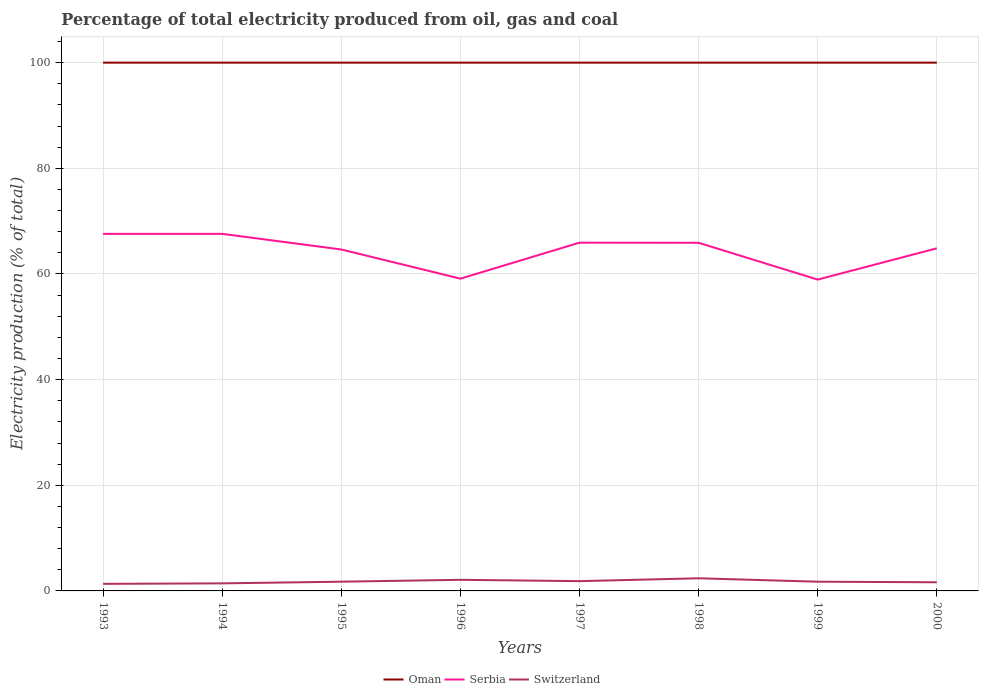How many different coloured lines are there?
Ensure brevity in your answer.  3. Does the line corresponding to Switzerland intersect with the line corresponding to Oman?
Provide a succinct answer. No. Across all years, what is the maximum electricity production in in Switzerland?
Ensure brevity in your answer.  1.34. What is the total electricity production in in Switzerland in the graph?
Ensure brevity in your answer.  -0.29. What is the difference between the highest and the second highest electricity production in in Serbia?
Ensure brevity in your answer.  8.66. What is the difference between the highest and the lowest electricity production in in Oman?
Provide a succinct answer. 0. How many lines are there?
Offer a terse response. 3. What is the difference between two consecutive major ticks on the Y-axis?
Provide a short and direct response. 20. Are the values on the major ticks of Y-axis written in scientific E-notation?
Offer a very short reply. No. Does the graph contain grids?
Keep it short and to the point. Yes. How many legend labels are there?
Provide a short and direct response. 3. How are the legend labels stacked?
Provide a succinct answer. Horizontal. What is the title of the graph?
Your answer should be very brief. Percentage of total electricity produced from oil, gas and coal. Does "South Sudan" appear as one of the legend labels in the graph?
Provide a succinct answer. No. What is the label or title of the Y-axis?
Ensure brevity in your answer.  Electricity production (% of total). What is the Electricity production (% of total) in Oman in 1993?
Your answer should be very brief. 100. What is the Electricity production (% of total) in Serbia in 1993?
Ensure brevity in your answer.  67.59. What is the Electricity production (% of total) in Switzerland in 1993?
Provide a short and direct response. 1.34. What is the Electricity production (% of total) of Serbia in 1994?
Provide a short and direct response. 67.59. What is the Electricity production (% of total) of Switzerland in 1994?
Your response must be concise. 1.43. What is the Electricity production (% of total) of Oman in 1995?
Your response must be concise. 100. What is the Electricity production (% of total) of Serbia in 1995?
Make the answer very short. 64.63. What is the Electricity production (% of total) of Switzerland in 1995?
Offer a terse response. 1.75. What is the Electricity production (% of total) in Serbia in 1996?
Offer a very short reply. 59.11. What is the Electricity production (% of total) of Switzerland in 1996?
Your answer should be very brief. 2.1. What is the Electricity production (% of total) in Oman in 1997?
Your answer should be compact. 100. What is the Electricity production (% of total) of Serbia in 1997?
Your answer should be compact. 65.92. What is the Electricity production (% of total) of Switzerland in 1997?
Provide a succinct answer. 1.85. What is the Electricity production (% of total) in Oman in 1998?
Ensure brevity in your answer.  100. What is the Electricity production (% of total) in Serbia in 1998?
Ensure brevity in your answer.  65.9. What is the Electricity production (% of total) in Switzerland in 1998?
Your answer should be very brief. 2.39. What is the Electricity production (% of total) of Oman in 1999?
Your response must be concise. 100. What is the Electricity production (% of total) in Serbia in 1999?
Your answer should be very brief. 58.93. What is the Electricity production (% of total) of Switzerland in 1999?
Your answer should be very brief. 1.74. What is the Electricity production (% of total) of Serbia in 2000?
Provide a short and direct response. 64.85. What is the Electricity production (% of total) of Switzerland in 2000?
Offer a terse response. 1.64. Across all years, what is the maximum Electricity production (% of total) of Oman?
Make the answer very short. 100. Across all years, what is the maximum Electricity production (% of total) in Serbia?
Offer a terse response. 67.59. Across all years, what is the maximum Electricity production (% of total) in Switzerland?
Your answer should be compact. 2.39. Across all years, what is the minimum Electricity production (% of total) in Oman?
Ensure brevity in your answer.  100. Across all years, what is the minimum Electricity production (% of total) of Serbia?
Offer a terse response. 58.93. Across all years, what is the minimum Electricity production (% of total) of Switzerland?
Offer a terse response. 1.34. What is the total Electricity production (% of total) in Oman in the graph?
Provide a short and direct response. 800. What is the total Electricity production (% of total) in Serbia in the graph?
Keep it short and to the point. 514.53. What is the total Electricity production (% of total) in Switzerland in the graph?
Make the answer very short. 14.25. What is the difference between the Electricity production (% of total) in Oman in 1993 and that in 1994?
Provide a short and direct response. 0. What is the difference between the Electricity production (% of total) of Serbia in 1993 and that in 1994?
Make the answer very short. 0. What is the difference between the Electricity production (% of total) in Switzerland in 1993 and that in 1994?
Make the answer very short. -0.09. What is the difference between the Electricity production (% of total) in Serbia in 1993 and that in 1995?
Ensure brevity in your answer.  2.96. What is the difference between the Electricity production (% of total) in Switzerland in 1993 and that in 1995?
Your answer should be very brief. -0.41. What is the difference between the Electricity production (% of total) of Oman in 1993 and that in 1996?
Your response must be concise. 0. What is the difference between the Electricity production (% of total) in Serbia in 1993 and that in 1996?
Offer a very short reply. 8.48. What is the difference between the Electricity production (% of total) of Switzerland in 1993 and that in 1996?
Make the answer very short. -0.76. What is the difference between the Electricity production (% of total) of Serbia in 1993 and that in 1997?
Your answer should be compact. 1.67. What is the difference between the Electricity production (% of total) in Switzerland in 1993 and that in 1997?
Your response must be concise. -0.51. What is the difference between the Electricity production (% of total) in Serbia in 1993 and that in 1998?
Ensure brevity in your answer.  1.69. What is the difference between the Electricity production (% of total) in Switzerland in 1993 and that in 1998?
Give a very brief answer. -1.05. What is the difference between the Electricity production (% of total) in Oman in 1993 and that in 1999?
Give a very brief answer. 0. What is the difference between the Electricity production (% of total) of Serbia in 1993 and that in 1999?
Your answer should be compact. 8.66. What is the difference between the Electricity production (% of total) of Switzerland in 1993 and that in 1999?
Give a very brief answer. -0.41. What is the difference between the Electricity production (% of total) of Oman in 1993 and that in 2000?
Make the answer very short. 0. What is the difference between the Electricity production (% of total) in Serbia in 1993 and that in 2000?
Offer a very short reply. 2.74. What is the difference between the Electricity production (% of total) in Switzerland in 1993 and that in 2000?
Offer a very short reply. -0.3. What is the difference between the Electricity production (% of total) in Serbia in 1994 and that in 1995?
Offer a very short reply. 2.96. What is the difference between the Electricity production (% of total) in Switzerland in 1994 and that in 1995?
Give a very brief answer. -0.32. What is the difference between the Electricity production (% of total) of Serbia in 1994 and that in 1996?
Offer a very short reply. 8.48. What is the difference between the Electricity production (% of total) of Switzerland in 1994 and that in 1996?
Make the answer very short. -0.67. What is the difference between the Electricity production (% of total) in Serbia in 1994 and that in 1997?
Offer a terse response. 1.67. What is the difference between the Electricity production (% of total) in Switzerland in 1994 and that in 1997?
Provide a short and direct response. -0.42. What is the difference between the Electricity production (% of total) of Oman in 1994 and that in 1998?
Keep it short and to the point. 0. What is the difference between the Electricity production (% of total) of Serbia in 1994 and that in 1998?
Keep it short and to the point. 1.69. What is the difference between the Electricity production (% of total) in Switzerland in 1994 and that in 1998?
Ensure brevity in your answer.  -0.96. What is the difference between the Electricity production (% of total) in Serbia in 1994 and that in 1999?
Provide a succinct answer. 8.66. What is the difference between the Electricity production (% of total) of Switzerland in 1994 and that in 1999?
Make the answer very short. -0.31. What is the difference between the Electricity production (% of total) of Serbia in 1994 and that in 2000?
Make the answer very short. 2.74. What is the difference between the Electricity production (% of total) in Switzerland in 1994 and that in 2000?
Make the answer very short. -0.21. What is the difference between the Electricity production (% of total) of Serbia in 1995 and that in 1996?
Offer a terse response. 5.53. What is the difference between the Electricity production (% of total) of Switzerland in 1995 and that in 1996?
Keep it short and to the point. -0.35. What is the difference between the Electricity production (% of total) of Oman in 1995 and that in 1997?
Your response must be concise. 0. What is the difference between the Electricity production (% of total) of Serbia in 1995 and that in 1997?
Your answer should be compact. -1.29. What is the difference between the Electricity production (% of total) in Switzerland in 1995 and that in 1997?
Your answer should be very brief. -0.1. What is the difference between the Electricity production (% of total) in Oman in 1995 and that in 1998?
Your answer should be very brief. 0. What is the difference between the Electricity production (% of total) of Serbia in 1995 and that in 1998?
Your answer should be compact. -1.27. What is the difference between the Electricity production (% of total) in Switzerland in 1995 and that in 1998?
Make the answer very short. -0.65. What is the difference between the Electricity production (% of total) in Serbia in 1995 and that in 1999?
Provide a succinct answer. 5.7. What is the difference between the Electricity production (% of total) of Switzerland in 1995 and that in 1999?
Offer a very short reply. 0. What is the difference between the Electricity production (% of total) in Oman in 1995 and that in 2000?
Keep it short and to the point. 0. What is the difference between the Electricity production (% of total) of Serbia in 1995 and that in 2000?
Ensure brevity in your answer.  -0.22. What is the difference between the Electricity production (% of total) in Switzerland in 1995 and that in 2000?
Your answer should be very brief. 0.11. What is the difference between the Electricity production (% of total) in Oman in 1996 and that in 1997?
Provide a short and direct response. 0. What is the difference between the Electricity production (% of total) in Serbia in 1996 and that in 1997?
Provide a succinct answer. -6.81. What is the difference between the Electricity production (% of total) of Switzerland in 1996 and that in 1997?
Keep it short and to the point. 0.25. What is the difference between the Electricity production (% of total) in Oman in 1996 and that in 1998?
Keep it short and to the point. 0. What is the difference between the Electricity production (% of total) of Serbia in 1996 and that in 1998?
Ensure brevity in your answer.  -6.79. What is the difference between the Electricity production (% of total) of Switzerland in 1996 and that in 1998?
Offer a terse response. -0.29. What is the difference between the Electricity production (% of total) of Serbia in 1996 and that in 1999?
Offer a terse response. 0.17. What is the difference between the Electricity production (% of total) in Switzerland in 1996 and that in 1999?
Your answer should be very brief. 0.36. What is the difference between the Electricity production (% of total) in Oman in 1996 and that in 2000?
Your answer should be compact. 0. What is the difference between the Electricity production (% of total) in Serbia in 1996 and that in 2000?
Your answer should be compact. -5.74. What is the difference between the Electricity production (% of total) of Switzerland in 1996 and that in 2000?
Offer a terse response. 0.46. What is the difference between the Electricity production (% of total) of Oman in 1997 and that in 1998?
Give a very brief answer. 0. What is the difference between the Electricity production (% of total) in Serbia in 1997 and that in 1998?
Offer a terse response. 0.02. What is the difference between the Electricity production (% of total) in Switzerland in 1997 and that in 1998?
Your answer should be compact. -0.54. What is the difference between the Electricity production (% of total) in Serbia in 1997 and that in 1999?
Provide a short and direct response. 6.99. What is the difference between the Electricity production (% of total) of Switzerland in 1997 and that in 1999?
Offer a terse response. 0.11. What is the difference between the Electricity production (% of total) in Serbia in 1997 and that in 2000?
Ensure brevity in your answer.  1.07. What is the difference between the Electricity production (% of total) in Switzerland in 1997 and that in 2000?
Make the answer very short. 0.21. What is the difference between the Electricity production (% of total) of Oman in 1998 and that in 1999?
Your answer should be very brief. 0. What is the difference between the Electricity production (% of total) of Serbia in 1998 and that in 1999?
Your answer should be compact. 6.97. What is the difference between the Electricity production (% of total) of Switzerland in 1998 and that in 1999?
Keep it short and to the point. 0.65. What is the difference between the Electricity production (% of total) of Oman in 1998 and that in 2000?
Your response must be concise. 0. What is the difference between the Electricity production (% of total) of Serbia in 1998 and that in 2000?
Keep it short and to the point. 1.05. What is the difference between the Electricity production (% of total) in Switzerland in 1998 and that in 2000?
Ensure brevity in your answer.  0.75. What is the difference between the Electricity production (% of total) in Oman in 1999 and that in 2000?
Provide a short and direct response. 0. What is the difference between the Electricity production (% of total) of Serbia in 1999 and that in 2000?
Ensure brevity in your answer.  -5.92. What is the difference between the Electricity production (% of total) in Switzerland in 1999 and that in 2000?
Provide a short and direct response. 0.11. What is the difference between the Electricity production (% of total) of Oman in 1993 and the Electricity production (% of total) of Serbia in 1994?
Make the answer very short. 32.41. What is the difference between the Electricity production (% of total) of Oman in 1993 and the Electricity production (% of total) of Switzerland in 1994?
Your answer should be compact. 98.57. What is the difference between the Electricity production (% of total) of Serbia in 1993 and the Electricity production (% of total) of Switzerland in 1994?
Provide a short and direct response. 66.16. What is the difference between the Electricity production (% of total) of Oman in 1993 and the Electricity production (% of total) of Serbia in 1995?
Offer a terse response. 35.37. What is the difference between the Electricity production (% of total) of Oman in 1993 and the Electricity production (% of total) of Switzerland in 1995?
Your answer should be very brief. 98.25. What is the difference between the Electricity production (% of total) of Serbia in 1993 and the Electricity production (% of total) of Switzerland in 1995?
Offer a terse response. 65.84. What is the difference between the Electricity production (% of total) of Oman in 1993 and the Electricity production (% of total) of Serbia in 1996?
Keep it short and to the point. 40.89. What is the difference between the Electricity production (% of total) of Oman in 1993 and the Electricity production (% of total) of Switzerland in 1996?
Provide a succinct answer. 97.9. What is the difference between the Electricity production (% of total) in Serbia in 1993 and the Electricity production (% of total) in Switzerland in 1996?
Your answer should be very brief. 65.49. What is the difference between the Electricity production (% of total) of Oman in 1993 and the Electricity production (% of total) of Serbia in 1997?
Offer a very short reply. 34.08. What is the difference between the Electricity production (% of total) of Oman in 1993 and the Electricity production (% of total) of Switzerland in 1997?
Give a very brief answer. 98.15. What is the difference between the Electricity production (% of total) of Serbia in 1993 and the Electricity production (% of total) of Switzerland in 1997?
Offer a very short reply. 65.74. What is the difference between the Electricity production (% of total) of Oman in 1993 and the Electricity production (% of total) of Serbia in 1998?
Your answer should be compact. 34.1. What is the difference between the Electricity production (% of total) in Oman in 1993 and the Electricity production (% of total) in Switzerland in 1998?
Your answer should be compact. 97.61. What is the difference between the Electricity production (% of total) of Serbia in 1993 and the Electricity production (% of total) of Switzerland in 1998?
Ensure brevity in your answer.  65.2. What is the difference between the Electricity production (% of total) of Oman in 1993 and the Electricity production (% of total) of Serbia in 1999?
Your answer should be compact. 41.07. What is the difference between the Electricity production (% of total) of Oman in 1993 and the Electricity production (% of total) of Switzerland in 1999?
Provide a succinct answer. 98.26. What is the difference between the Electricity production (% of total) in Serbia in 1993 and the Electricity production (% of total) in Switzerland in 1999?
Provide a succinct answer. 65.85. What is the difference between the Electricity production (% of total) in Oman in 1993 and the Electricity production (% of total) in Serbia in 2000?
Your response must be concise. 35.15. What is the difference between the Electricity production (% of total) in Oman in 1993 and the Electricity production (% of total) in Switzerland in 2000?
Offer a terse response. 98.36. What is the difference between the Electricity production (% of total) in Serbia in 1993 and the Electricity production (% of total) in Switzerland in 2000?
Ensure brevity in your answer.  65.95. What is the difference between the Electricity production (% of total) in Oman in 1994 and the Electricity production (% of total) in Serbia in 1995?
Offer a very short reply. 35.37. What is the difference between the Electricity production (% of total) in Oman in 1994 and the Electricity production (% of total) in Switzerland in 1995?
Your answer should be very brief. 98.25. What is the difference between the Electricity production (% of total) of Serbia in 1994 and the Electricity production (% of total) of Switzerland in 1995?
Your response must be concise. 65.84. What is the difference between the Electricity production (% of total) of Oman in 1994 and the Electricity production (% of total) of Serbia in 1996?
Offer a terse response. 40.89. What is the difference between the Electricity production (% of total) in Oman in 1994 and the Electricity production (% of total) in Switzerland in 1996?
Provide a short and direct response. 97.9. What is the difference between the Electricity production (% of total) in Serbia in 1994 and the Electricity production (% of total) in Switzerland in 1996?
Give a very brief answer. 65.49. What is the difference between the Electricity production (% of total) of Oman in 1994 and the Electricity production (% of total) of Serbia in 1997?
Offer a very short reply. 34.08. What is the difference between the Electricity production (% of total) of Oman in 1994 and the Electricity production (% of total) of Switzerland in 1997?
Provide a succinct answer. 98.15. What is the difference between the Electricity production (% of total) of Serbia in 1994 and the Electricity production (% of total) of Switzerland in 1997?
Give a very brief answer. 65.74. What is the difference between the Electricity production (% of total) of Oman in 1994 and the Electricity production (% of total) of Serbia in 1998?
Your answer should be compact. 34.1. What is the difference between the Electricity production (% of total) of Oman in 1994 and the Electricity production (% of total) of Switzerland in 1998?
Provide a short and direct response. 97.61. What is the difference between the Electricity production (% of total) of Serbia in 1994 and the Electricity production (% of total) of Switzerland in 1998?
Keep it short and to the point. 65.2. What is the difference between the Electricity production (% of total) in Oman in 1994 and the Electricity production (% of total) in Serbia in 1999?
Make the answer very short. 41.07. What is the difference between the Electricity production (% of total) of Oman in 1994 and the Electricity production (% of total) of Switzerland in 1999?
Your answer should be compact. 98.26. What is the difference between the Electricity production (% of total) of Serbia in 1994 and the Electricity production (% of total) of Switzerland in 1999?
Your answer should be compact. 65.85. What is the difference between the Electricity production (% of total) of Oman in 1994 and the Electricity production (% of total) of Serbia in 2000?
Make the answer very short. 35.15. What is the difference between the Electricity production (% of total) of Oman in 1994 and the Electricity production (% of total) of Switzerland in 2000?
Give a very brief answer. 98.36. What is the difference between the Electricity production (% of total) of Serbia in 1994 and the Electricity production (% of total) of Switzerland in 2000?
Ensure brevity in your answer.  65.95. What is the difference between the Electricity production (% of total) of Oman in 1995 and the Electricity production (% of total) of Serbia in 1996?
Your answer should be very brief. 40.89. What is the difference between the Electricity production (% of total) in Oman in 1995 and the Electricity production (% of total) in Switzerland in 1996?
Your answer should be very brief. 97.9. What is the difference between the Electricity production (% of total) of Serbia in 1995 and the Electricity production (% of total) of Switzerland in 1996?
Make the answer very short. 62.53. What is the difference between the Electricity production (% of total) of Oman in 1995 and the Electricity production (% of total) of Serbia in 1997?
Offer a very short reply. 34.08. What is the difference between the Electricity production (% of total) in Oman in 1995 and the Electricity production (% of total) in Switzerland in 1997?
Make the answer very short. 98.15. What is the difference between the Electricity production (% of total) of Serbia in 1995 and the Electricity production (% of total) of Switzerland in 1997?
Keep it short and to the point. 62.78. What is the difference between the Electricity production (% of total) in Oman in 1995 and the Electricity production (% of total) in Serbia in 1998?
Your answer should be very brief. 34.1. What is the difference between the Electricity production (% of total) of Oman in 1995 and the Electricity production (% of total) of Switzerland in 1998?
Provide a succinct answer. 97.61. What is the difference between the Electricity production (% of total) of Serbia in 1995 and the Electricity production (% of total) of Switzerland in 1998?
Your answer should be very brief. 62.24. What is the difference between the Electricity production (% of total) in Oman in 1995 and the Electricity production (% of total) in Serbia in 1999?
Your response must be concise. 41.07. What is the difference between the Electricity production (% of total) in Oman in 1995 and the Electricity production (% of total) in Switzerland in 1999?
Provide a succinct answer. 98.26. What is the difference between the Electricity production (% of total) of Serbia in 1995 and the Electricity production (% of total) of Switzerland in 1999?
Ensure brevity in your answer.  62.89. What is the difference between the Electricity production (% of total) of Oman in 1995 and the Electricity production (% of total) of Serbia in 2000?
Offer a terse response. 35.15. What is the difference between the Electricity production (% of total) of Oman in 1995 and the Electricity production (% of total) of Switzerland in 2000?
Make the answer very short. 98.36. What is the difference between the Electricity production (% of total) in Serbia in 1995 and the Electricity production (% of total) in Switzerland in 2000?
Provide a short and direct response. 62.99. What is the difference between the Electricity production (% of total) of Oman in 1996 and the Electricity production (% of total) of Serbia in 1997?
Provide a succinct answer. 34.08. What is the difference between the Electricity production (% of total) of Oman in 1996 and the Electricity production (% of total) of Switzerland in 1997?
Provide a succinct answer. 98.15. What is the difference between the Electricity production (% of total) of Serbia in 1996 and the Electricity production (% of total) of Switzerland in 1997?
Give a very brief answer. 57.26. What is the difference between the Electricity production (% of total) in Oman in 1996 and the Electricity production (% of total) in Serbia in 1998?
Keep it short and to the point. 34.1. What is the difference between the Electricity production (% of total) in Oman in 1996 and the Electricity production (% of total) in Switzerland in 1998?
Your answer should be compact. 97.61. What is the difference between the Electricity production (% of total) in Serbia in 1996 and the Electricity production (% of total) in Switzerland in 1998?
Your answer should be compact. 56.71. What is the difference between the Electricity production (% of total) in Oman in 1996 and the Electricity production (% of total) in Serbia in 1999?
Make the answer very short. 41.07. What is the difference between the Electricity production (% of total) of Oman in 1996 and the Electricity production (% of total) of Switzerland in 1999?
Offer a very short reply. 98.26. What is the difference between the Electricity production (% of total) in Serbia in 1996 and the Electricity production (% of total) in Switzerland in 1999?
Ensure brevity in your answer.  57.36. What is the difference between the Electricity production (% of total) of Oman in 1996 and the Electricity production (% of total) of Serbia in 2000?
Make the answer very short. 35.15. What is the difference between the Electricity production (% of total) in Oman in 1996 and the Electricity production (% of total) in Switzerland in 2000?
Give a very brief answer. 98.36. What is the difference between the Electricity production (% of total) in Serbia in 1996 and the Electricity production (% of total) in Switzerland in 2000?
Your answer should be very brief. 57.47. What is the difference between the Electricity production (% of total) in Oman in 1997 and the Electricity production (% of total) in Serbia in 1998?
Your answer should be compact. 34.1. What is the difference between the Electricity production (% of total) of Oman in 1997 and the Electricity production (% of total) of Switzerland in 1998?
Keep it short and to the point. 97.61. What is the difference between the Electricity production (% of total) in Serbia in 1997 and the Electricity production (% of total) in Switzerland in 1998?
Ensure brevity in your answer.  63.53. What is the difference between the Electricity production (% of total) of Oman in 1997 and the Electricity production (% of total) of Serbia in 1999?
Your answer should be very brief. 41.07. What is the difference between the Electricity production (% of total) of Oman in 1997 and the Electricity production (% of total) of Switzerland in 1999?
Ensure brevity in your answer.  98.26. What is the difference between the Electricity production (% of total) of Serbia in 1997 and the Electricity production (% of total) of Switzerland in 1999?
Provide a short and direct response. 64.18. What is the difference between the Electricity production (% of total) of Oman in 1997 and the Electricity production (% of total) of Serbia in 2000?
Provide a succinct answer. 35.15. What is the difference between the Electricity production (% of total) in Oman in 1997 and the Electricity production (% of total) in Switzerland in 2000?
Your answer should be very brief. 98.36. What is the difference between the Electricity production (% of total) in Serbia in 1997 and the Electricity production (% of total) in Switzerland in 2000?
Provide a succinct answer. 64.28. What is the difference between the Electricity production (% of total) in Oman in 1998 and the Electricity production (% of total) in Serbia in 1999?
Your response must be concise. 41.07. What is the difference between the Electricity production (% of total) of Oman in 1998 and the Electricity production (% of total) of Switzerland in 1999?
Ensure brevity in your answer.  98.26. What is the difference between the Electricity production (% of total) of Serbia in 1998 and the Electricity production (% of total) of Switzerland in 1999?
Your answer should be very brief. 64.16. What is the difference between the Electricity production (% of total) in Oman in 1998 and the Electricity production (% of total) in Serbia in 2000?
Make the answer very short. 35.15. What is the difference between the Electricity production (% of total) of Oman in 1998 and the Electricity production (% of total) of Switzerland in 2000?
Offer a terse response. 98.36. What is the difference between the Electricity production (% of total) in Serbia in 1998 and the Electricity production (% of total) in Switzerland in 2000?
Provide a short and direct response. 64.26. What is the difference between the Electricity production (% of total) in Oman in 1999 and the Electricity production (% of total) in Serbia in 2000?
Keep it short and to the point. 35.15. What is the difference between the Electricity production (% of total) of Oman in 1999 and the Electricity production (% of total) of Switzerland in 2000?
Your response must be concise. 98.36. What is the difference between the Electricity production (% of total) of Serbia in 1999 and the Electricity production (% of total) of Switzerland in 2000?
Your answer should be compact. 57.3. What is the average Electricity production (% of total) in Oman per year?
Ensure brevity in your answer.  100. What is the average Electricity production (% of total) in Serbia per year?
Your answer should be compact. 64.32. What is the average Electricity production (% of total) of Switzerland per year?
Give a very brief answer. 1.78. In the year 1993, what is the difference between the Electricity production (% of total) in Oman and Electricity production (% of total) in Serbia?
Keep it short and to the point. 32.41. In the year 1993, what is the difference between the Electricity production (% of total) of Oman and Electricity production (% of total) of Switzerland?
Provide a short and direct response. 98.66. In the year 1993, what is the difference between the Electricity production (% of total) in Serbia and Electricity production (% of total) in Switzerland?
Your response must be concise. 66.25. In the year 1994, what is the difference between the Electricity production (% of total) of Oman and Electricity production (% of total) of Serbia?
Provide a short and direct response. 32.41. In the year 1994, what is the difference between the Electricity production (% of total) of Oman and Electricity production (% of total) of Switzerland?
Offer a very short reply. 98.57. In the year 1994, what is the difference between the Electricity production (% of total) in Serbia and Electricity production (% of total) in Switzerland?
Keep it short and to the point. 66.16. In the year 1995, what is the difference between the Electricity production (% of total) of Oman and Electricity production (% of total) of Serbia?
Provide a succinct answer. 35.37. In the year 1995, what is the difference between the Electricity production (% of total) of Oman and Electricity production (% of total) of Switzerland?
Provide a short and direct response. 98.25. In the year 1995, what is the difference between the Electricity production (% of total) in Serbia and Electricity production (% of total) in Switzerland?
Ensure brevity in your answer.  62.89. In the year 1996, what is the difference between the Electricity production (% of total) of Oman and Electricity production (% of total) of Serbia?
Your response must be concise. 40.89. In the year 1996, what is the difference between the Electricity production (% of total) in Oman and Electricity production (% of total) in Switzerland?
Your answer should be very brief. 97.9. In the year 1996, what is the difference between the Electricity production (% of total) of Serbia and Electricity production (% of total) of Switzerland?
Provide a short and direct response. 57.01. In the year 1997, what is the difference between the Electricity production (% of total) of Oman and Electricity production (% of total) of Serbia?
Your response must be concise. 34.08. In the year 1997, what is the difference between the Electricity production (% of total) of Oman and Electricity production (% of total) of Switzerland?
Your answer should be very brief. 98.15. In the year 1997, what is the difference between the Electricity production (% of total) in Serbia and Electricity production (% of total) in Switzerland?
Keep it short and to the point. 64.07. In the year 1998, what is the difference between the Electricity production (% of total) in Oman and Electricity production (% of total) in Serbia?
Offer a very short reply. 34.1. In the year 1998, what is the difference between the Electricity production (% of total) in Oman and Electricity production (% of total) in Switzerland?
Ensure brevity in your answer.  97.61. In the year 1998, what is the difference between the Electricity production (% of total) in Serbia and Electricity production (% of total) in Switzerland?
Ensure brevity in your answer.  63.51. In the year 1999, what is the difference between the Electricity production (% of total) of Oman and Electricity production (% of total) of Serbia?
Your response must be concise. 41.07. In the year 1999, what is the difference between the Electricity production (% of total) in Oman and Electricity production (% of total) in Switzerland?
Your response must be concise. 98.26. In the year 1999, what is the difference between the Electricity production (% of total) in Serbia and Electricity production (% of total) in Switzerland?
Give a very brief answer. 57.19. In the year 2000, what is the difference between the Electricity production (% of total) in Oman and Electricity production (% of total) in Serbia?
Give a very brief answer. 35.15. In the year 2000, what is the difference between the Electricity production (% of total) in Oman and Electricity production (% of total) in Switzerland?
Give a very brief answer. 98.36. In the year 2000, what is the difference between the Electricity production (% of total) of Serbia and Electricity production (% of total) of Switzerland?
Ensure brevity in your answer.  63.21. What is the ratio of the Electricity production (% of total) in Oman in 1993 to that in 1994?
Keep it short and to the point. 1. What is the ratio of the Electricity production (% of total) of Switzerland in 1993 to that in 1994?
Provide a succinct answer. 0.94. What is the ratio of the Electricity production (% of total) of Serbia in 1993 to that in 1995?
Offer a terse response. 1.05. What is the ratio of the Electricity production (% of total) of Switzerland in 1993 to that in 1995?
Give a very brief answer. 0.77. What is the ratio of the Electricity production (% of total) in Oman in 1993 to that in 1996?
Offer a very short reply. 1. What is the ratio of the Electricity production (% of total) of Serbia in 1993 to that in 1996?
Keep it short and to the point. 1.14. What is the ratio of the Electricity production (% of total) in Switzerland in 1993 to that in 1996?
Provide a short and direct response. 0.64. What is the ratio of the Electricity production (% of total) in Serbia in 1993 to that in 1997?
Your answer should be very brief. 1.03. What is the ratio of the Electricity production (% of total) in Switzerland in 1993 to that in 1997?
Offer a very short reply. 0.72. What is the ratio of the Electricity production (% of total) in Oman in 1993 to that in 1998?
Your answer should be very brief. 1. What is the ratio of the Electricity production (% of total) of Serbia in 1993 to that in 1998?
Provide a succinct answer. 1.03. What is the ratio of the Electricity production (% of total) in Switzerland in 1993 to that in 1998?
Keep it short and to the point. 0.56. What is the ratio of the Electricity production (% of total) in Oman in 1993 to that in 1999?
Your response must be concise. 1. What is the ratio of the Electricity production (% of total) of Serbia in 1993 to that in 1999?
Your answer should be very brief. 1.15. What is the ratio of the Electricity production (% of total) of Switzerland in 1993 to that in 1999?
Make the answer very short. 0.77. What is the ratio of the Electricity production (% of total) in Serbia in 1993 to that in 2000?
Make the answer very short. 1.04. What is the ratio of the Electricity production (% of total) in Switzerland in 1993 to that in 2000?
Provide a short and direct response. 0.82. What is the ratio of the Electricity production (% of total) of Serbia in 1994 to that in 1995?
Provide a succinct answer. 1.05. What is the ratio of the Electricity production (% of total) of Switzerland in 1994 to that in 1995?
Your answer should be very brief. 0.82. What is the ratio of the Electricity production (% of total) of Oman in 1994 to that in 1996?
Your answer should be very brief. 1. What is the ratio of the Electricity production (% of total) in Serbia in 1994 to that in 1996?
Make the answer very short. 1.14. What is the ratio of the Electricity production (% of total) of Switzerland in 1994 to that in 1996?
Provide a succinct answer. 0.68. What is the ratio of the Electricity production (% of total) in Serbia in 1994 to that in 1997?
Ensure brevity in your answer.  1.03. What is the ratio of the Electricity production (% of total) in Switzerland in 1994 to that in 1997?
Your response must be concise. 0.77. What is the ratio of the Electricity production (% of total) of Serbia in 1994 to that in 1998?
Provide a short and direct response. 1.03. What is the ratio of the Electricity production (% of total) of Switzerland in 1994 to that in 1998?
Give a very brief answer. 0.6. What is the ratio of the Electricity production (% of total) of Serbia in 1994 to that in 1999?
Give a very brief answer. 1.15. What is the ratio of the Electricity production (% of total) in Switzerland in 1994 to that in 1999?
Your answer should be very brief. 0.82. What is the ratio of the Electricity production (% of total) in Oman in 1994 to that in 2000?
Keep it short and to the point. 1. What is the ratio of the Electricity production (% of total) of Serbia in 1994 to that in 2000?
Keep it short and to the point. 1.04. What is the ratio of the Electricity production (% of total) in Switzerland in 1994 to that in 2000?
Your answer should be very brief. 0.87. What is the ratio of the Electricity production (% of total) of Serbia in 1995 to that in 1996?
Give a very brief answer. 1.09. What is the ratio of the Electricity production (% of total) of Switzerland in 1995 to that in 1996?
Ensure brevity in your answer.  0.83. What is the ratio of the Electricity production (% of total) in Oman in 1995 to that in 1997?
Offer a very short reply. 1. What is the ratio of the Electricity production (% of total) of Serbia in 1995 to that in 1997?
Ensure brevity in your answer.  0.98. What is the ratio of the Electricity production (% of total) of Switzerland in 1995 to that in 1997?
Your response must be concise. 0.94. What is the ratio of the Electricity production (% of total) in Serbia in 1995 to that in 1998?
Provide a succinct answer. 0.98. What is the ratio of the Electricity production (% of total) of Switzerland in 1995 to that in 1998?
Provide a succinct answer. 0.73. What is the ratio of the Electricity production (% of total) of Oman in 1995 to that in 1999?
Make the answer very short. 1. What is the ratio of the Electricity production (% of total) of Serbia in 1995 to that in 1999?
Keep it short and to the point. 1.1. What is the ratio of the Electricity production (% of total) in Switzerland in 1995 to that in 1999?
Provide a short and direct response. 1. What is the ratio of the Electricity production (% of total) of Oman in 1995 to that in 2000?
Offer a terse response. 1. What is the ratio of the Electricity production (% of total) of Serbia in 1995 to that in 2000?
Your answer should be very brief. 1. What is the ratio of the Electricity production (% of total) in Switzerland in 1995 to that in 2000?
Provide a succinct answer. 1.07. What is the ratio of the Electricity production (% of total) in Oman in 1996 to that in 1997?
Your answer should be very brief. 1. What is the ratio of the Electricity production (% of total) of Serbia in 1996 to that in 1997?
Give a very brief answer. 0.9. What is the ratio of the Electricity production (% of total) of Switzerland in 1996 to that in 1997?
Provide a short and direct response. 1.13. What is the ratio of the Electricity production (% of total) in Serbia in 1996 to that in 1998?
Provide a short and direct response. 0.9. What is the ratio of the Electricity production (% of total) of Switzerland in 1996 to that in 1998?
Give a very brief answer. 0.88. What is the ratio of the Electricity production (% of total) of Serbia in 1996 to that in 1999?
Provide a short and direct response. 1. What is the ratio of the Electricity production (% of total) of Switzerland in 1996 to that in 1999?
Ensure brevity in your answer.  1.2. What is the ratio of the Electricity production (% of total) of Oman in 1996 to that in 2000?
Ensure brevity in your answer.  1. What is the ratio of the Electricity production (% of total) of Serbia in 1996 to that in 2000?
Your answer should be very brief. 0.91. What is the ratio of the Electricity production (% of total) of Switzerland in 1996 to that in 2000?
Give a very brief answer. 1.28. What is the ratio of the Electricity production (% of total) of Switzerland in 1997 to that in 1998?
Your response must be concise. 0.77. What is the ratio of the Electricity production (% of total) of Oman in 1997 to that in 1999?
Your answer should be compact. 1. What is the ratio of the Electricity production (% of total) of Serbia in 1997 to that in 1999?
Keep it short and to the point. 1.12. What is the ratio of the Electricity production (% of total) of Switzerland in 1997 to that in 1999?
Provide a short and direct response. 1.06. What is the ratio of the Electricity production (% of total) in Serbia in 1997 to that in 2000?
Your answer should be compact. 1.02. What is the ratio of the Electricity production (% of total) in Switzerland in 1997 to that in 2000?
Ensure brevity in your answer.  1.13. What is the ratio of the Electricity production (% of total) of Serbia in 1998 to that in 1999?
Your response must be concise. 1.12. What is the ratio of the Electricity production (% of total) in Switzerland in 1998 to that in 1999?
Give a very brief answer. 1.37. What is the ratio of the Electricity production (% of total) in Serbia in 1998 to that in 2000?
Your response must be concise. 1.02. What is the ratio of the Electricity production (% of total) of Switzerland in 1998 to that in 2000?
Give a very brief answer. 1.46. What is the ratio of the Electricity production (% of total) of Serbia in 1999 to that in 2000?
Make the answer very short. 0.91. What is the ratio of the Electricity production (% of total) in Switzerland in 1999 to that in 2000?
Provide a short and direct response. 1.06. What is the difference between the highest and the second highest Electricity production (% of total) in Serbia?
Your response must be concise. 0. What is the difference between the highest and the second highest Electricity production (% of total) in Switzerland?
Your answer should be very brief. 0.29. What is the difference between the highest and the lowest Electricity production (% of total) of Serbia?
Ensure brevity in your answer.  8.66. What is the difference between the highest and the lowest Electricity production (% of total) of Switzerland?
Provide a succinct answer. 1.05. 